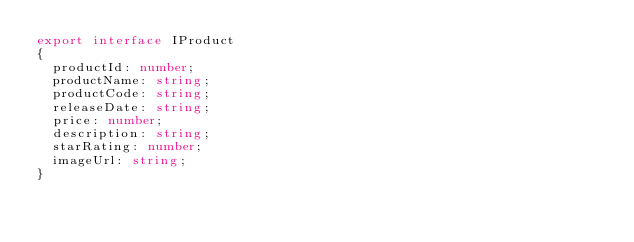<code> <loc_0><loc_0><loc_500><loc_500><_TypeScript_>export interface IProduct
{
  productId: number;
  productName: string;
  productCode: string;
  releaseDate: string;
  price: number;
  description: string;
  starRating: number;
  imageUrl: string;
}
</code> 